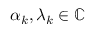<formula> <loc_0><loc_0><loc_500><loc_500>\alpha _ { k } , \lambda _ { k } \in \mathbb { C }</formula> 